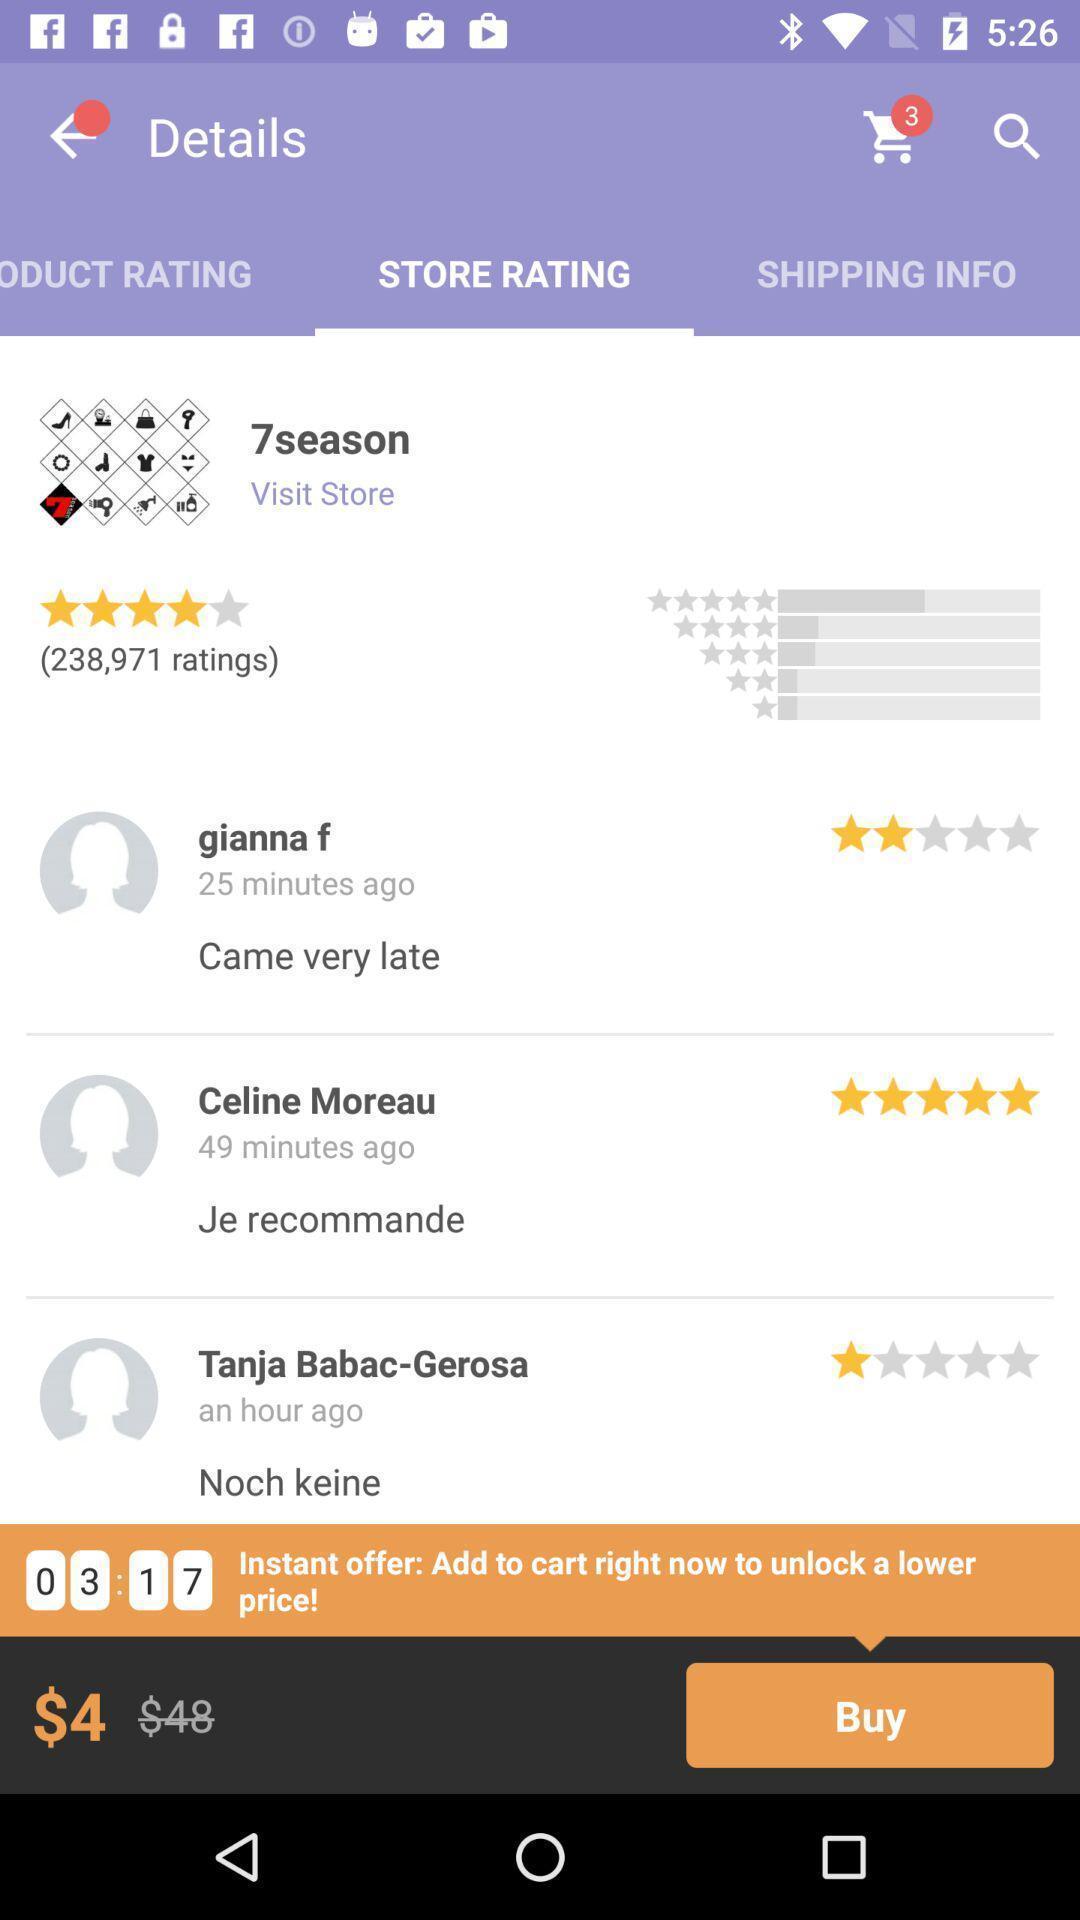Tell me about the visual elements in this screen capture. Screen displaying multiple user comments and price details. 